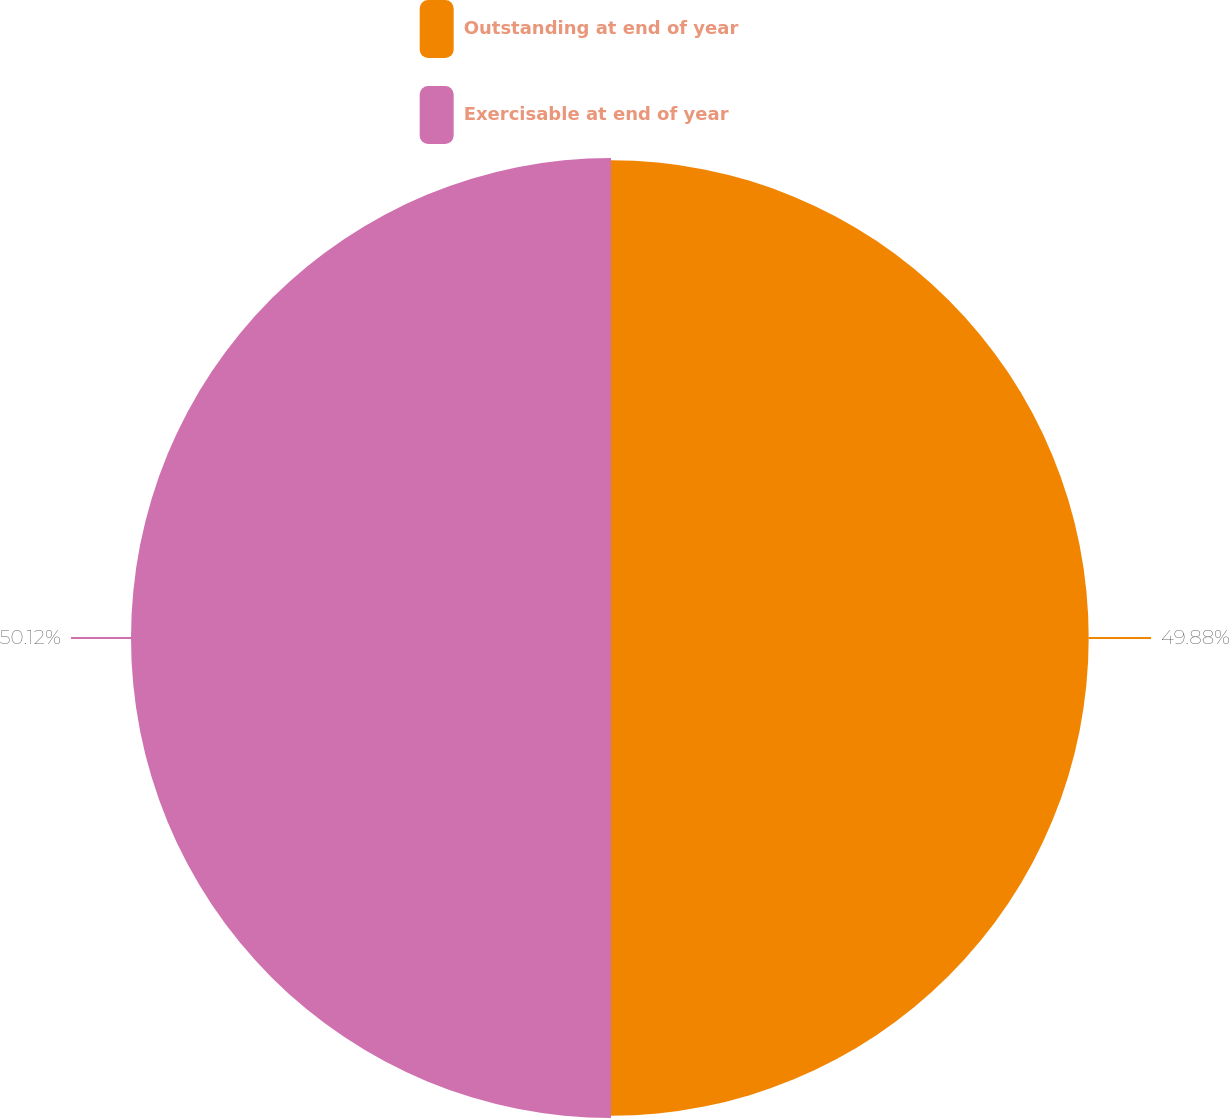<chart> <loc_0><loc_0><loc_500><loc_500><pie_chart><fcel>Outstanding at end of year<fcel>Exercisable at end of year<nl><fcel>49.88%<fcel>50.12%<nl></chart> 